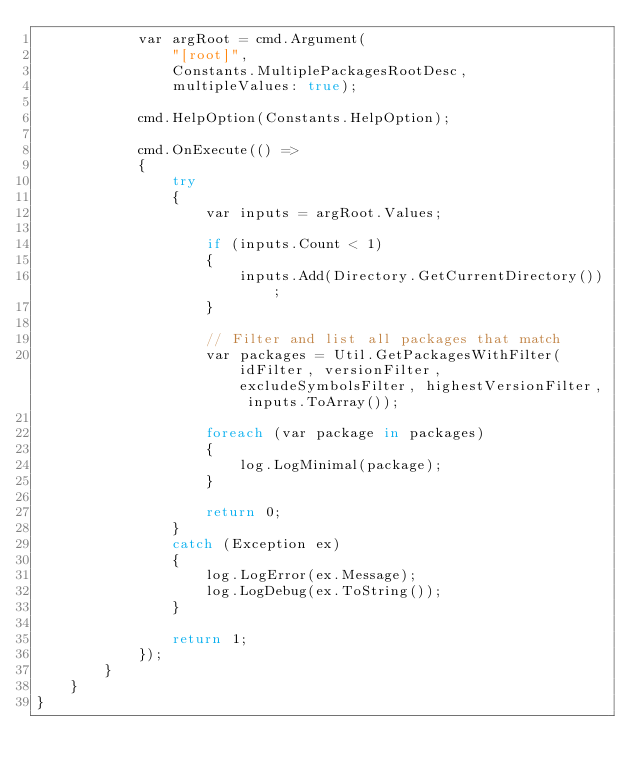Convert code to text. <code><loc_0><loc_0><loc_500><loc_500><_C#_>            var argRoot = cmd.Argument(
                "[root]",
                Constants.MultiplePackagesRootDesc,
                multipleValues: true);

            cmd.HelpOption(Constants.HelpOption);

            cmd.OnExecute(() =>
            {
                try
                {
                    var inputs = argRoot.Values;

                    if (inputs.Count < 1)
                    {
                        inputs.Add(Directory.GetCurrentDirectory());
                    }

                    // Filter and list all packages that match
                    var packages = Util.GetPackagesWithFilter(idFilter, versionFilter, excludeSymbolsFilter, highestVersionFilter, inputs.ToArray());

                    foreach (var package in packages)
                    {
                        log.LogMinimal(package);
                    }

                    return 0;
                }
                catch (Exception ex)
                {
                    log.LogError(ex.Message);
                    log.LogDebug(ex.ToString());
                }

                return 1;
            });
        }
    }
}</code> 